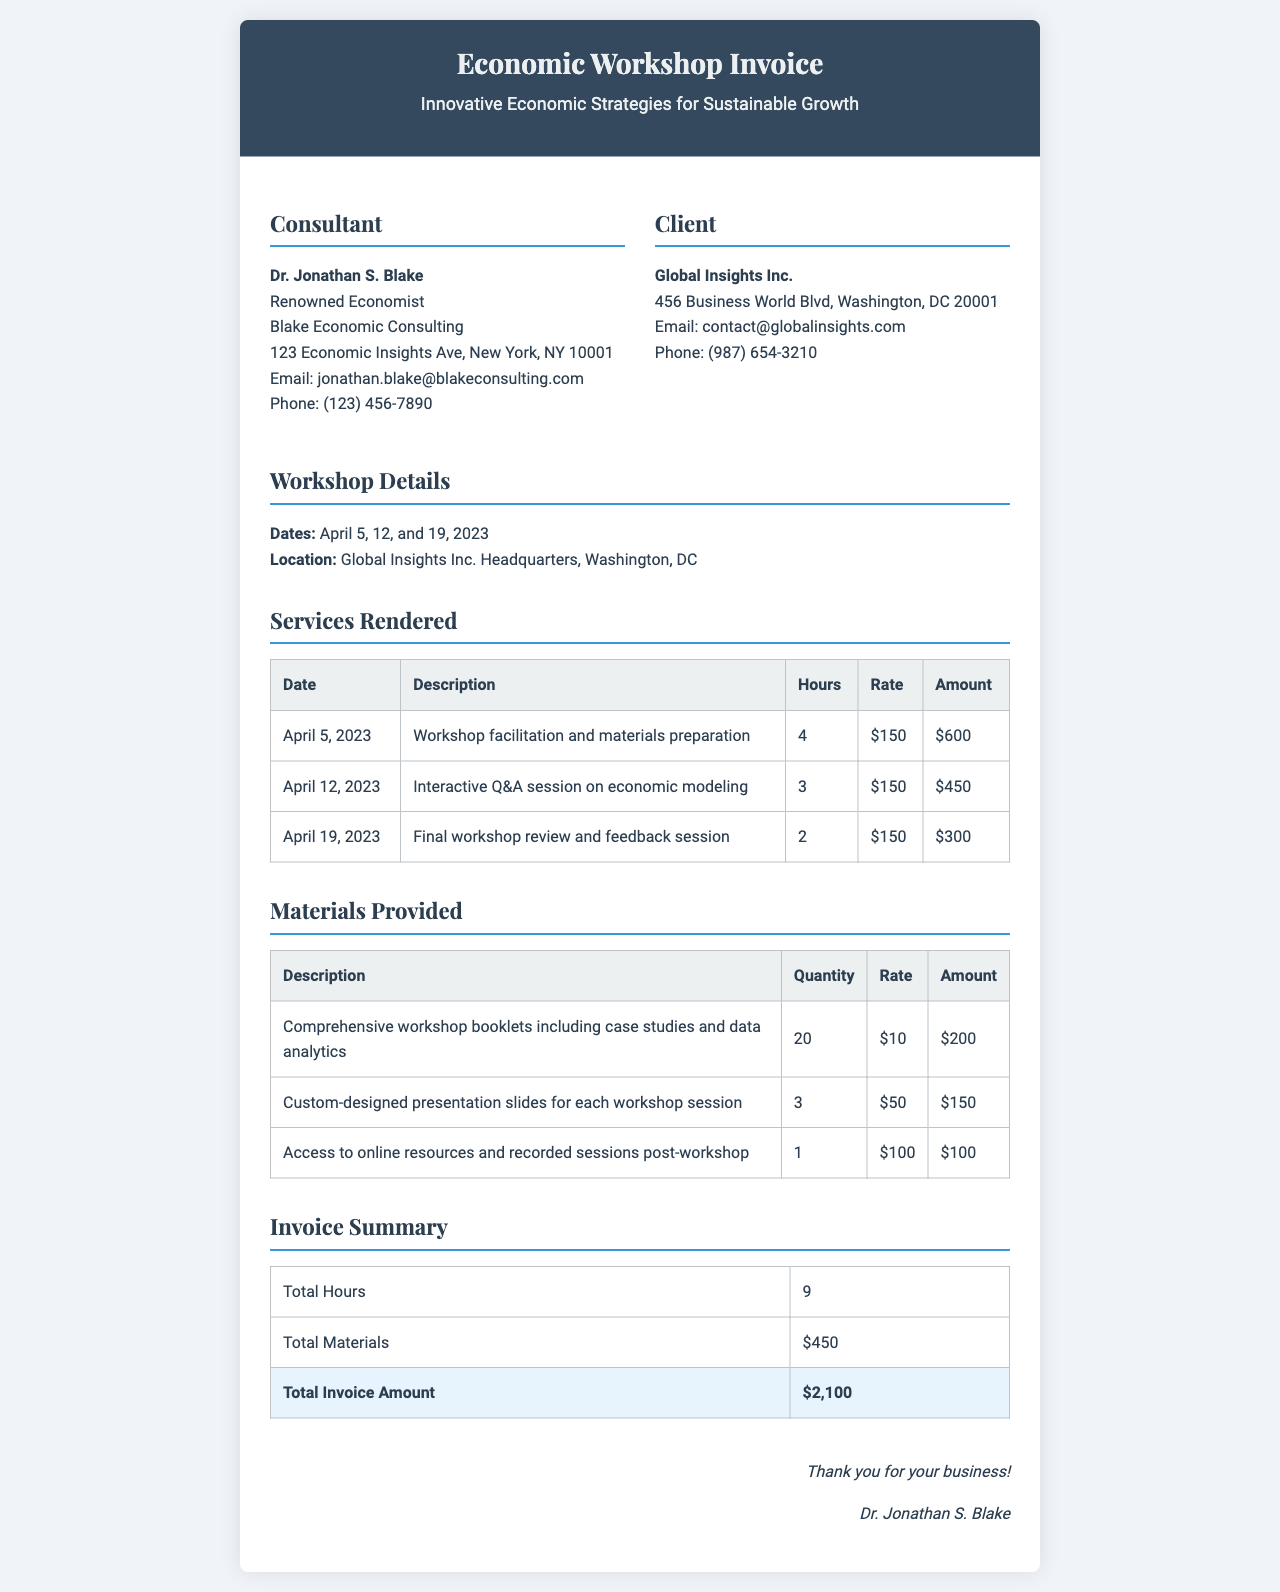What is the consultant's name? The consultant's name is mentioned at the top of the invoice under the "Consultant" section.
Answer: Dr. Jonathan S. Blake How many workshops were conducted? The invoice details three specific dates for workshops held in April 2023.
Answer: 3 What is the total amount billed for services rendered? The total invoice amount is listed in the "Invoice Summary" section.
Answer: $2,100 What were the total hours worked? The "Invoice Summary" section specifies the total hours worked on the workshops.
Answer: 9 What is the rate per hour for the consulting services? The invoice states that the hourly rate for the services rendered was consistent throughout.
Answer: $150 Which materials were provided? The "Materials Provided" section lists the descriptions of the items included.
Answer: Workshop booklets, presentation slides, online resources On what date was the interactive Q&A session held? This specific detail can be found in the "Services Rendered" table under the date column.
Answer: April 12, 2023 What is the total cost of materials provided? The total materials cost is calculated and shown in the "Invoice Summary" section.
Answer: $450 Where was the workshop conducted? The location is mentioned in the "Workshop Details" section of the invoice.
Answer: Global Insights Inc. Headquarters, Washington, DC 